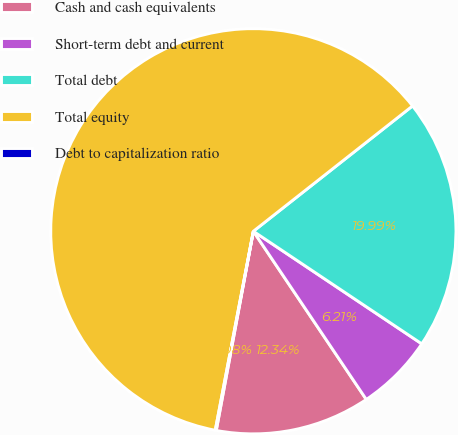Convert chart. <chart><loc_0><loc_0><loc_500><loc_500><pie_chart><fcel>Cash and cash equivalents<fcel>Short-term debt and current<fcel>Total debt<fcel>Total equity<fcel>Debt to capitalization ratio<nl><fcel>12.34%<fcel>6.21%<fcel>19.99%<fcel>61.37%<fcel>0.08%<nl></chart> 